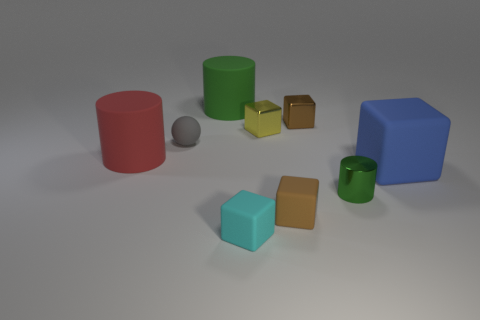Subtract all blue cubes. How many cubes are left? 4 Subtract all small cyan matte cubes. How many cubes are left? 4 Subtract 2 blocks. How many blocks are left? 3 Subtract all purple cubes. Subtract all yellow balls. How many cubes are left? 5 Add 1 large cyan rubber objects. How many objects exist? 10 Subtract all spheres. How many objects are left? 8 Subtract 0 purple spheres. How many objects are left? 9 Subtract all matte balls. Subtract all brown metal blocks. How many objects are left? 7 Add 8 green cylinders. How many green cylinders are left? 10 Add 7 big blue matte things. How many big blue matte things exist? 8 